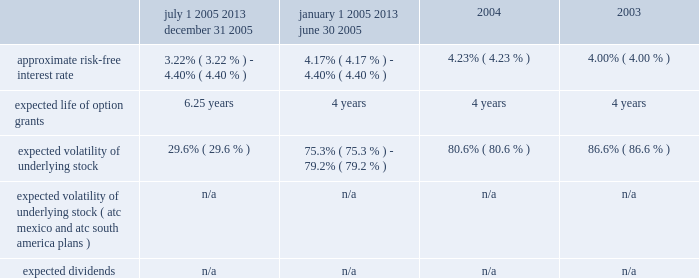American tower corporation and subsidiaries notes to consolidated financial statements 2014 ( continued ) 2003 were $ 10.08 , $ 7.05 , and $ 6.32 per share , respectively .
Key assumptions used to apply this pricing model are as follows : july 1 , 2005 2013 december 31 , 2005 january 1 , 2005 2013 june 30 , 2005 2004 2003 .
Voluntary option exchanges 2014in february 2004 , the company issued to eligible employees 1032717 options with an exercise price of $ 11.19 per share , the fair market value of the class a common stock on the date of grant .
These options were issued in connection with a voluntary option exchange program entered into by the company in august 2003 , pursuant to which the company accepted for surrender and cancelled options to purchase a total of 1831981 shares of its class a common stock having an exercise price of $ 10.25 or greater .
The program , which was offered to both full and part-time employees , excluding the company 2019s executive officers and its directors , provided for the grant ( at least six months and one day from the surrender date to employees still employed on that date ) of new options exercisable for two shares of class a common stock for every three shares of class a common stock issuable upon exercise of a surrendered option .
No options were granted to any employees who participated in the exchange offer between the cancellation date and the new grant atc mexico stock option plan 2014the company maintains a stock option plan in its atc mexico subsidiary ( atc mexico plan ) .
The atc mexico plan provides for the issuance of options to officers , employees , directors and consultants of atc mexico .
The atc mexico plan limits the number of shares of common stock which may be granted to an aggregate of 360 shares , subject to adjustment based on changes in atc mexico 2019s capital structure .
During 2002 , atc mexico granted options to purchase 318 shares of atc mexico common stock to officers and employees .
Such options were issued at one time with an exercise price of $ 10000 per share .
The exercise price per share was at fair market value as determined by the board of directors with the assistance of an independent appraisal performed at the company 2019s request .
The fair value of atc mexico plan options granted during 2002 were $ 3611 per share as determined by using the black-scholes option pricing model .
As described in note 11 , all outstanding options were exercised in march 2004 .
No options under the atc mexico plan were outstanding as of december 31 , 2005 .
( see note 11. ) atc south america stock option plan 2014the company maintains a stock option plan in its atc south america subsidiary ( atc south america plan ) .
The atc south america plan provides for the issuance of options to officers , employees , directors and consultants of atc south america .
The atc south america plan limits the number of shares of common stock which may be granted to an aggregate of 6144 shares , ( an approximate 10.3% ( 10.3 % ) interest on a fully-diluted basis ) , subject to adjustment based on changes in atc south america 2019s capital structure .
During 2004 , atc south america granted options to purchase 6024 shares of atc south america common stock to officers and employees , including messrs .
Gearon and hess , who received options to purchase an approximate 6.7% ( 6.7 % ) and 1.6% ( 1.6 % ) interest , respectively .
Such options were issued at one time with an exercise price of $ 1349 per share .
The exercise price per share was at fair market value on the date of issuance as determined by the board of directors with the assistance of an independent appraisal performed at the company 2019s request .
The fair value of atc south america plan options granted during 2004 were $ 79 per share as determined by using the black-scholes option pricing model .
Options granted vest upon the earlier to occur of ( a ) the exercise by or on behalf of mr .
Gearon of his right to sell his interest in atc south america to the company , ( b ) the .
What was the percentage change in the stock volatility from 2003 to 2004? 
Computations: ((80.6 - 86.6) / 86.6)
Answer: -0.06928. 